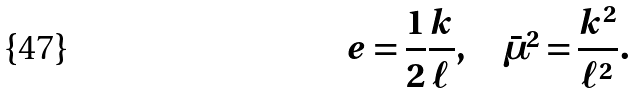<formula> <loc_0><loc_0><loc_500><loc_500>e = \frac { 1 } { 2 } \frac { k } { \ell } , \quad \bar { \mu } ^ { 2 } = \frac { k ^ { 2 } } { \ell ^ { 2 } } .</formula> 